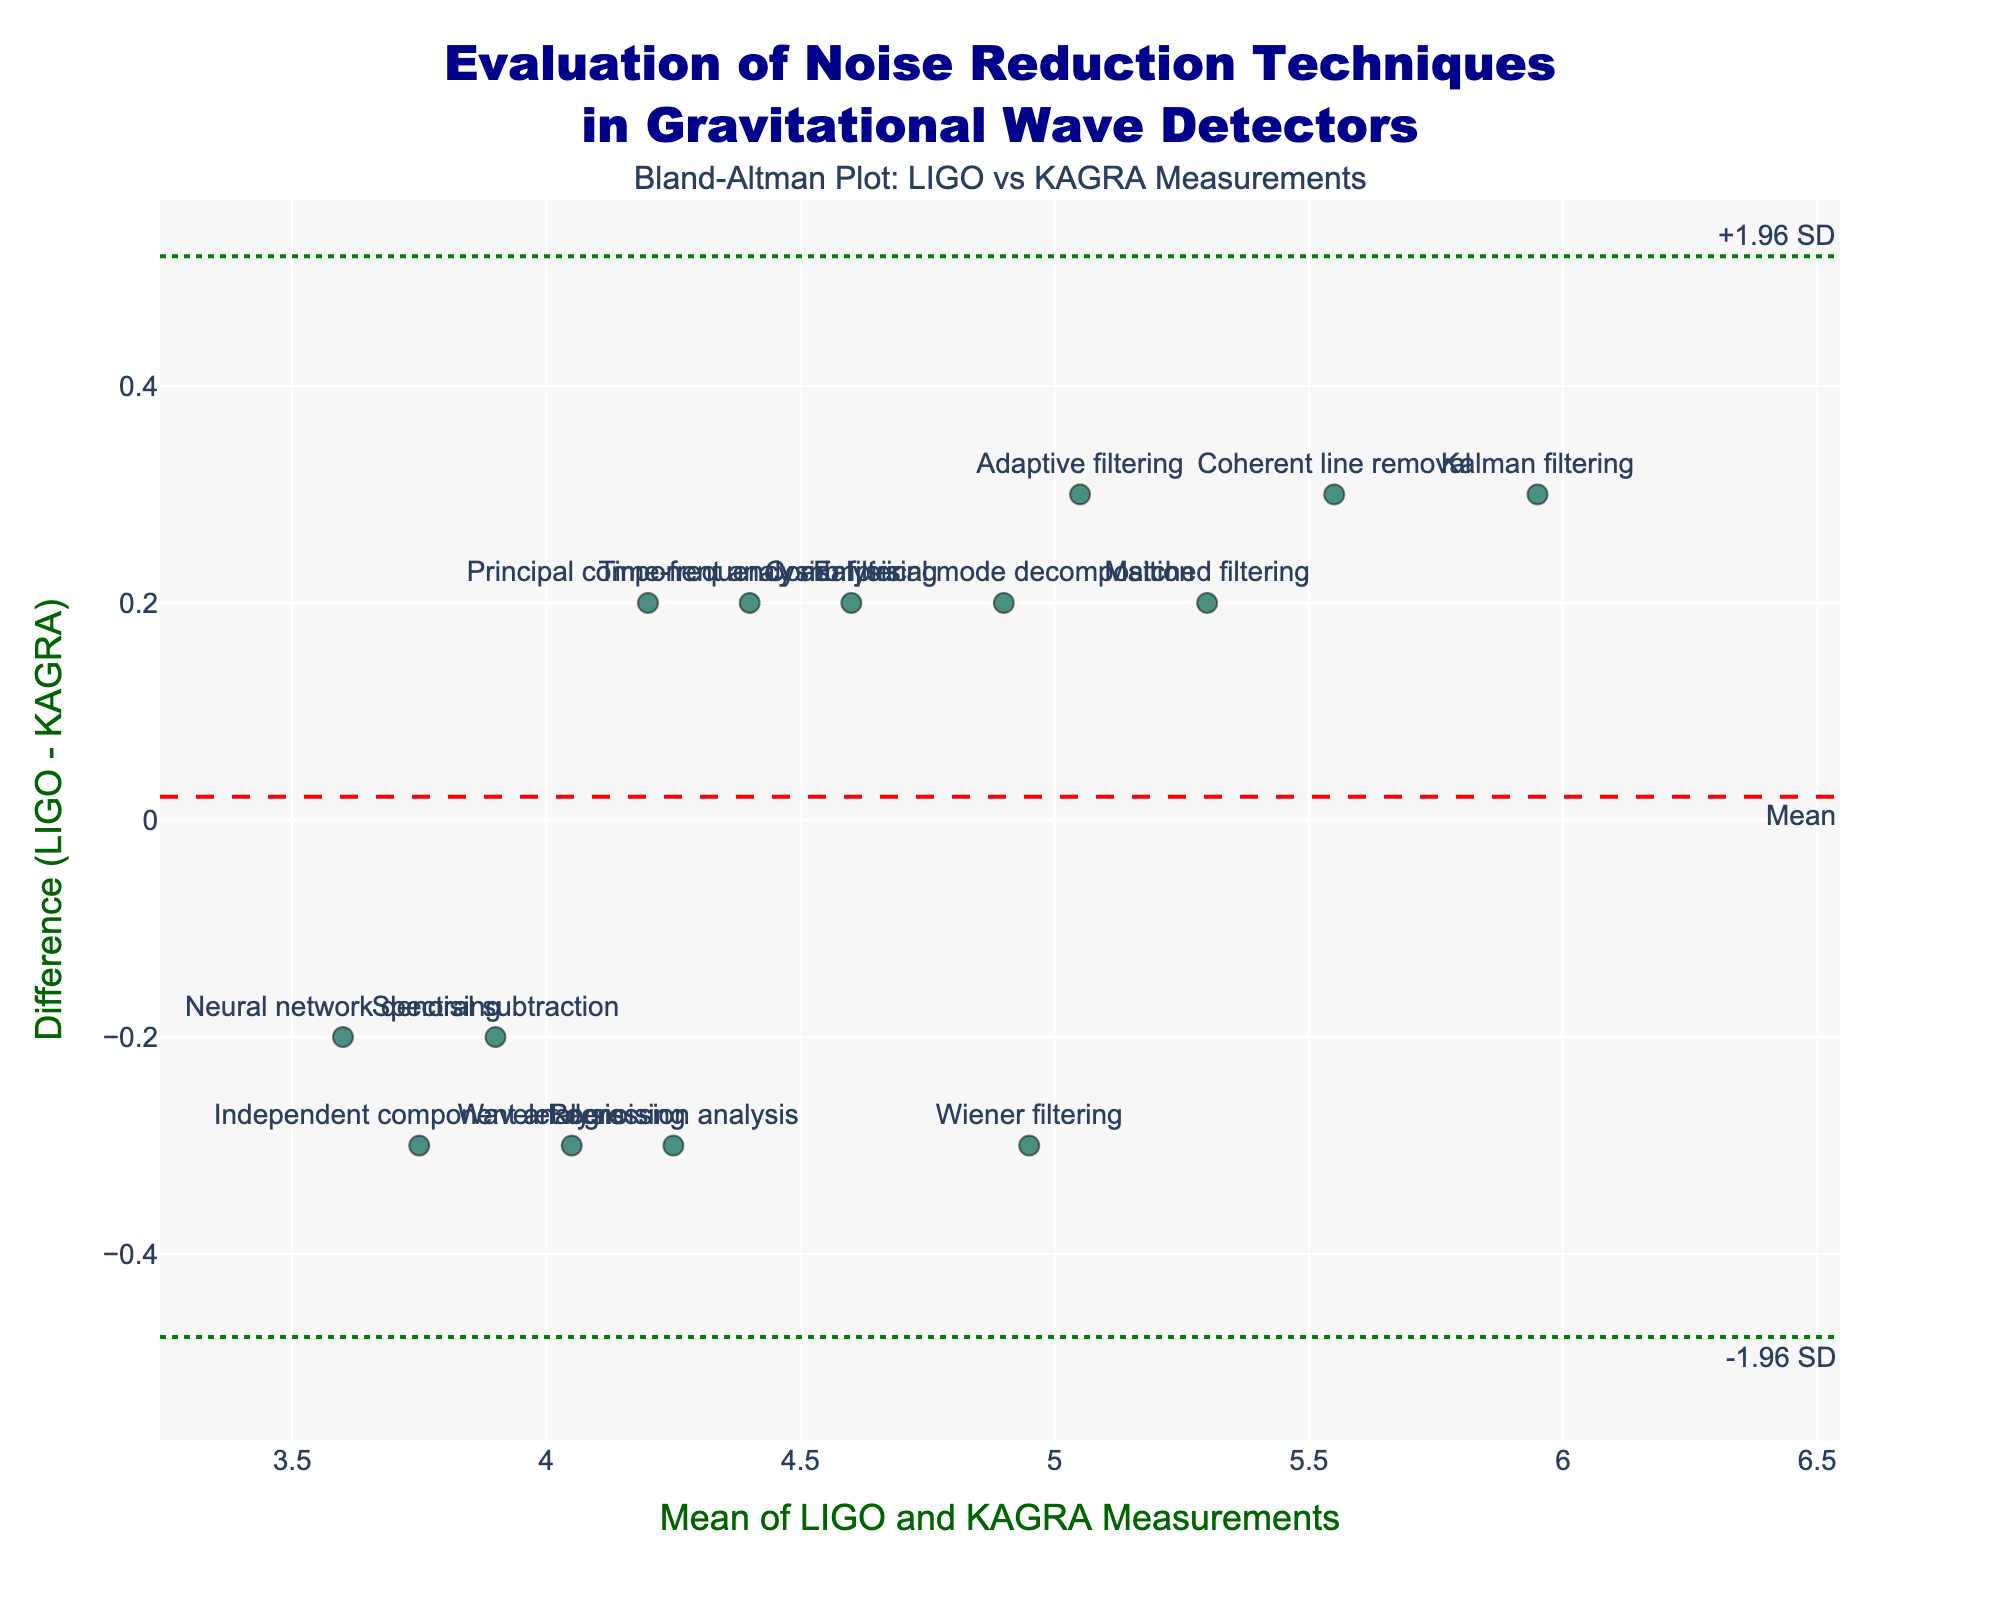What is the title of the plot? The title of the plot is located at the top center and it is written in a large font. It says "Evaluation of Noise Reduction Techniques in Gravitational Wave Detectors".
Answer: Evaluation of Noise Reduction Techniques in Gravitational Wave Detectors How many data points are represented in the Bland-Altman plot? To find the number of data points, count the number of markers in the scatter plot. Each marker represents a pair of measurements.
Answer: 14 What is the x-axis label of the plot? The x-axis label is located below the horizontal axis of the plot. It reads "Mean of LIGO and KAGRA Measurements".
Answer: Mean of LIGO and KAGRA Measurements Which noise reduction technique has the highest mean measurement in the plot? To find this, locate the marker with the highest x-coordinate value, which represents the highest mean measurement of the LIGO and KAGRA measurements.
Answer: Kalman filtering Which noise reduction technique has the largest difference between the LIGO and KAGRA measurements? To determine this, find the marker with the highest or lowest y-coordinate value, which represents the largest absolute difference between the LIGO and KAGRA measurements.
Answer: Kalman filtering What is the mean difference between the LIGO and KAGRA measurements? The mean difference is represented by a horizontal dashed red line. It is also labeled as "Mean" on the plot.
Answer: ~0.0 What are the approximate values of the limits of agreement shown in the plot? The limits of agreement are represented by the green dotted lines labeled "-1.96 SD" and "+1.96 SD". Their positions on the vertical axis indicate their approximate values.
Answer: Lower: ~-0.6, Upper: ~0.6 How many techniques have a LIGO measurement greater than the KAGRA measurement? Look for markers that are above the horizontal line at zero, as they represent cases where the difference (LIGO - KAGRA) is positive. Count these markers.
Answer: 7 Which technique shows the smallest difference between the LIGO and KAGRA measurements? Find the marker closest to the horizontal line at zero difference.
Answer: Matched filtering For the Adaptive filtering technique, is the KAGRA measurement higher or lower than the LIGO measurement? Locate the marker labeled "Adaptive filtering". Observe its position relative to the zero difference line. If it's below, KAGRA is higher; if it's above, KAGRA is lower.
Answer: Lower 